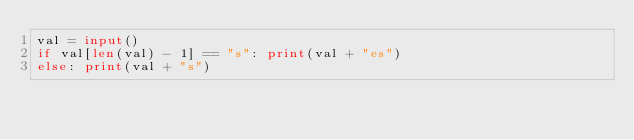Convert code to text. <code><loc_0><loc_0><loc_500><loc_500><_Python_>val = input()
if val[len(val) - 1] == "s": print(val + "es")
else: print(val + "s")</code> 